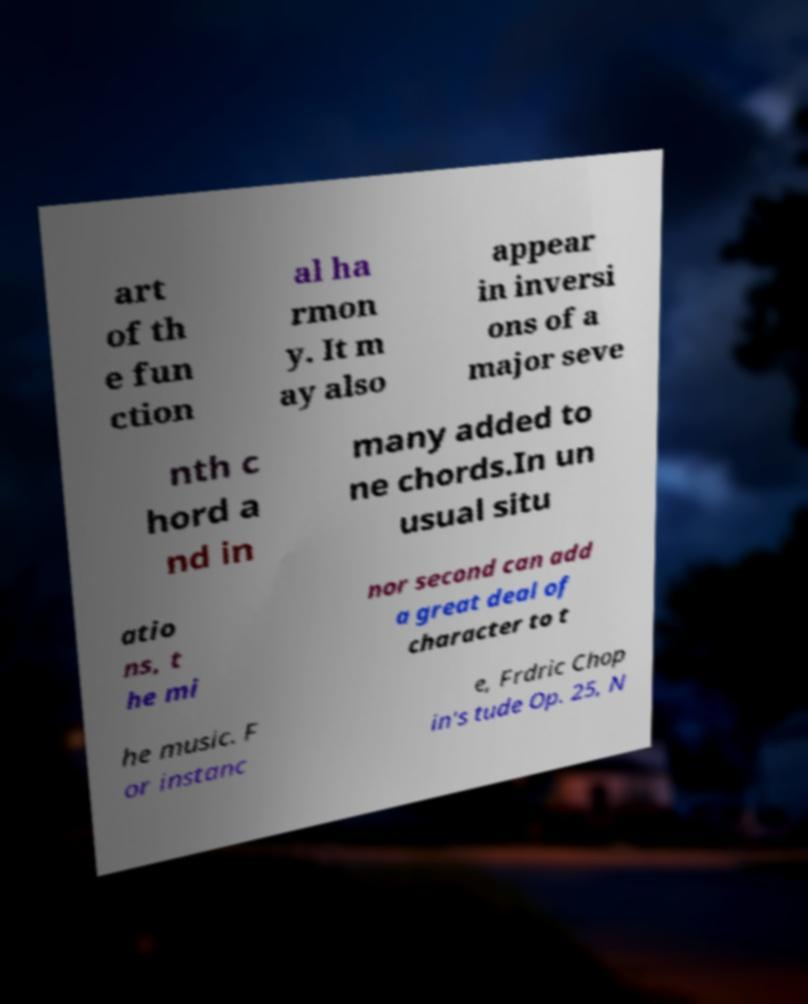Please read and relay the text visible in this image. What does it say? art of th e fun ction al ha rmon y. It m ay also appear in inversi ons of a major seve nth c hord a nd in many added to ne chords.In un usual situ atio ns, t he mi nor second can add a great deal of character to t he music. F or instanc e, Frdric Chop in's tude Op. 25, N 